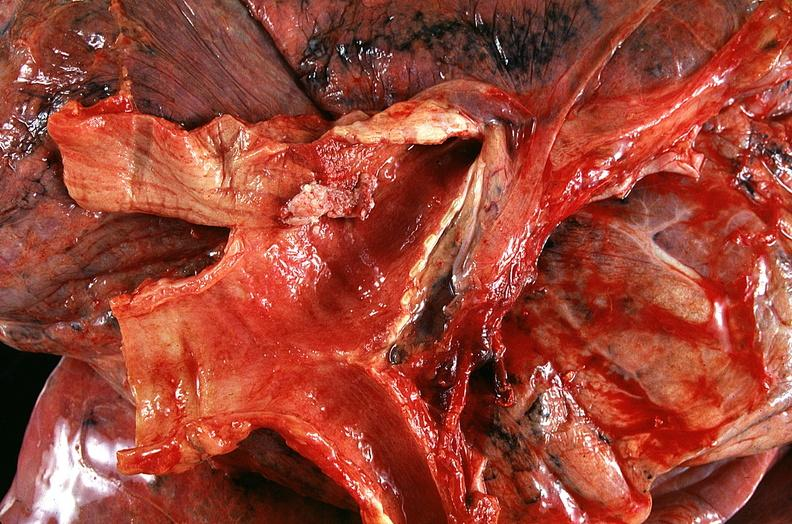does this image show lung, squamous cell carcinoma fungating lesion right mainstbronchus?
Answer the question using a single word or phrase. Yes 